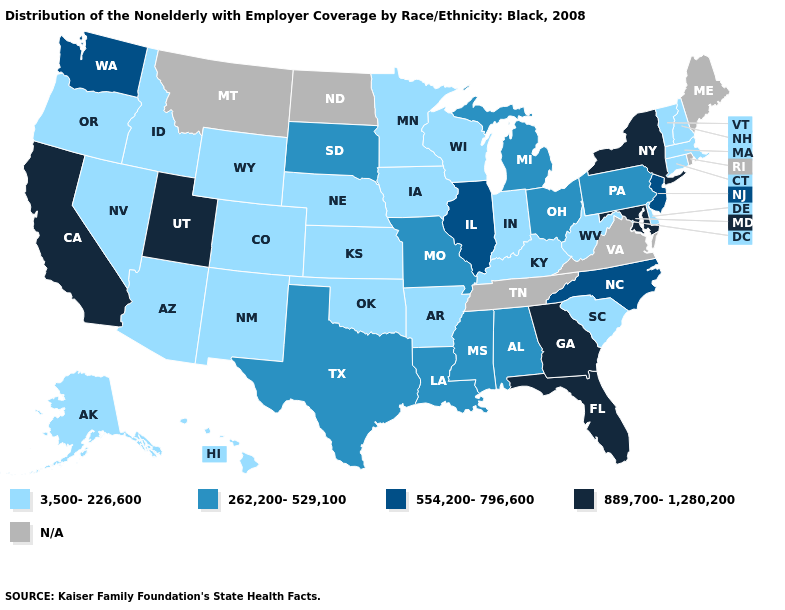What is the highest value in states that border Utah?
Give a very brief answer. 3,500-226,600. Does Florida have the lowest value in the South?
Keep it brief. No. What is the highest value in states that border New Hampshire?
Concise answer only. 3,500-226,600. What is the value of New Mexico?
Keep it brief. 3,500-226,600. Name the states that have a value in the range N/A?
Give a very brief answer. Maine, Montana, North Dakota, Rhode Island, Tennessee, Virginia. Does New York have the highest value in the USA?
Answer briefly. Yes. Does the first symbol in the legend represent the smallest category?
Answer briefly. Yes. Name the states that have a value in the range 3,500-226,600?
Be succinct. Alaska, Arizona, Arkansas, Colorado, Connecticut, Delaware, Hawaii, Idaho, Indiana, Iowa, Kansas, Kentucky, Massachusetts, Minnesota, Nebraska, Nevada, New Hampshire, New Mexico, Oklahoma, Oregon, South Carolina, Vermont, West Virginia, Wisconsin, Wyoming. What is the highest value in states that border Nevada?
Give a very brief answer. 889,700-1,280,200. Does New Jersey have the lowest value in the Northeast?
Concise answer only. No. Does Florida have the highest value in the USA?
Short answer required. Yes. What is the value of Tennessee?
Keep it brief. N/A. Name the states that have a value in the range 889,700-1,280,200?
Write a very short answer. California, Florida, Georgia, Maryland, New York, Utah. What is the value of Florida?
Keep it brief. 889,700-1,280,200. 